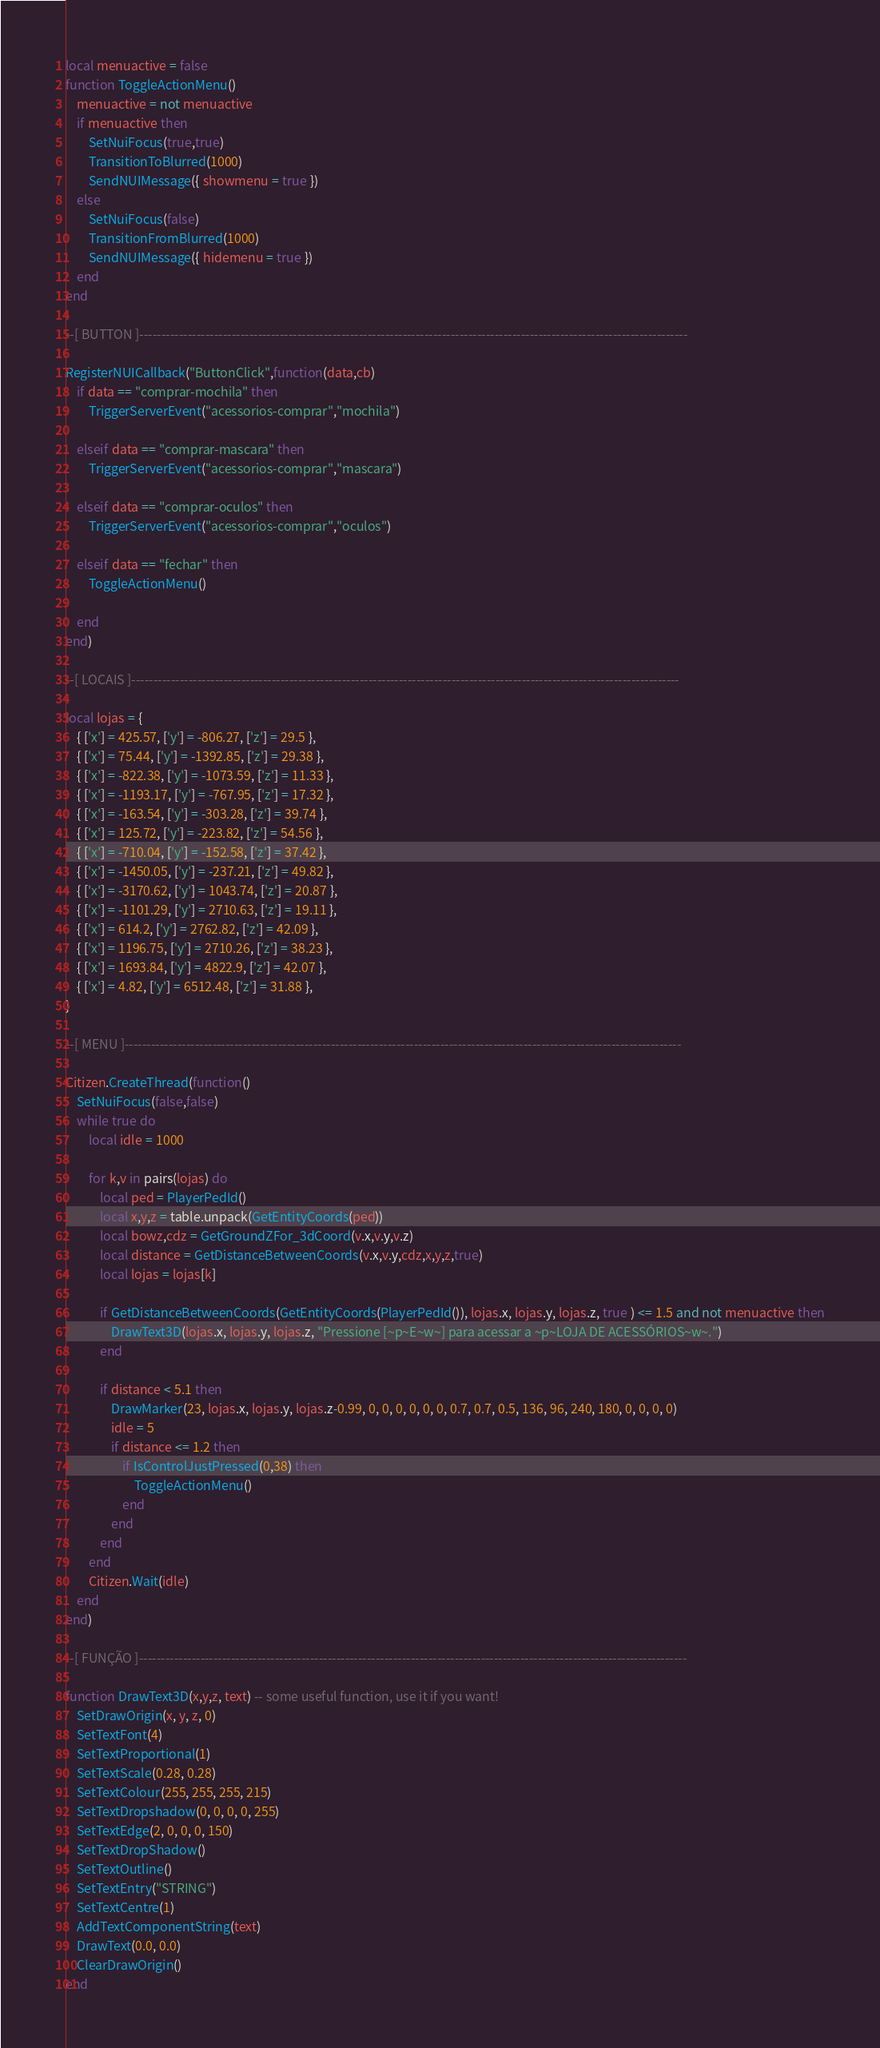<code> <loc_0><loc_0><loc_500><loc_500><_Lua_>local menuactive = false
function ToggleActionMenu()
	menuactive = not menuactive
	if menuactive then
		SetNuiFocus(true,true)
		TransitionToBlurred(1000)
		SendNUIMessage({ showmenu = true })
	else
		SetNuiFocus(false)
		TransitionFromBlurred(1000)
		SendNUIMessage({ hidemenu = true })
	end
end

--[ BUTTON ]-----------------------------------------------------------------------------------------------------------------------------

RegisterNUICallback("ButtonClick",function(data,cb)
	if data == "comprar-mochila" then
		TriggerServerEvent("acessorios-comprar","mochila")
	
	elseif data == "comprar-mascara" then
		TriggerServerEvent("acessorios-comprar","mascara")

	elseif data == "comprar-oculos" then
		TriggerServerEvent("acessorios-comprar","oculos")

	elseif data == "fechar" then
		ToggleActionMenu()
	
	end
end)

--[ LOCAIS ]-----------------------------------------------------------------------------------------------------------------------------

local lojas = {
	{ ['x'] = 425.57, ['y'] = -806.27, ['z'] = 29.5 },
	{ ['x'] = 75.44, ['y'] = -1392.85, ['z'] = 29.38 },
	{ ['x'] = -822.38, ['y'] = -1073.59, ['z'] = 11.33 },
	{ ['x'] = -1193.17, ['y'] = -767.95, ['z'] = 17.32 },
	{ ['x'] = -163.54, ['y'] = -303.28, ['z'] = 39.74 },
	{ ['x'] = 125.72, ['y'] = -223.82, ['z'] = 54.56 },
	{ ['x'] = -710.04, ['y'] = -152.58, ['z'] = 37.42 },
	{ ['x'] = -1450.05, ['y'] = -237.21, ['z'] = 49.82 },
	{ ['x'] = -3170.62, ['y'] = 1043.74, ['z'] = 20.87 },
	{ ['x'] = -1101.29, ['y'] = 2710.63, ['z'] = 19.11 },
	{ ['x'] = 614.2, ['y'] = 2762.82, ['z'] = 42.09 },
	{ ['x'] = 1196.75, ['y'] = 2710.26, ['z'] = 38.23 },
	{ ['x'] = 1693.84, ['y'] = 4822.9, ['z'] = 42.07 },
	{ ['x'] = 4.82, ['y'] = 6512.48, ['z'] = 31.88 },
}

--[ MENU ]-------------------------------------------------------------------------------------------------------------------------------

Citizen.CreateThread(function()
	SetNuiFocus(false,false)
	while true do
		local idle = 1000

		for k,v in pairs(lojas) do
			local ped = PlayerPedId()
			local x,y,z = table.unpack(GetEntityCoords(ped))
			local bowz,cdz = GetGroundZFor_3dCoord(v.x,v.y,v.z)
			local distance = GetDistanceBetweenCoords(v.x,v.y,cdz,x,y,z,true)
			local lojas = lojas[k]

			if GetDistanceBetweenCoords(GetEntityCoords(PlayerPedId()), lojas.x, lojas.y, lojas.z, true ) <= 1.5 and not menuactive then
				DrawText3D(lojas.x, lojas.y, lojas.z, "Pressione [~p~E~w~] para acessar a ~p~LOJA DE ACESSÓRIOS~w~.")
			end
			
			if distance < 5.1 then
				DrawMarker(23, lojas.x, lojas.y, lojas.z-0.99, 0, 0, 0, 0, 0, 0, 0.7, 0.7, 0.5, 136, 96, 240, 180, 0, 0, 0, 0)
				idle = 5
				if distance <= 1.2 then
					if IsControlJustPressed(0,38) then
						ToggleActionMenu()
					end
				end
			end
		end
		Citizen.Wait(idle)
	end
end)

--[ FUNÇÃO ]-----------------------------------------------------------------------------------------------------------------------------

function DrawText3D(x,y,z, text) -- some useful function, use it if you want! 
	SetDrawOrigin(x, y, z, 0)
	SetTextFont(4)
	SetTextProportional(1)
	SetTextScale(0.28, 0.28)
	SetTextColour(255, 255, 255, 215)
	SetTextDropshadow(0, 0, 0, 0, 255)
	SetTextEdge(2, 0, 0, 0, 150)
	SetTextDropShadow()
	SetTextOutline()
	SetTextEntry("STRING")
	SetTextCentre(1)
	AddTextComponentString(text)
	DrawText(0.0, 0.0)
	ClearDrawOrigin()
end</code> 